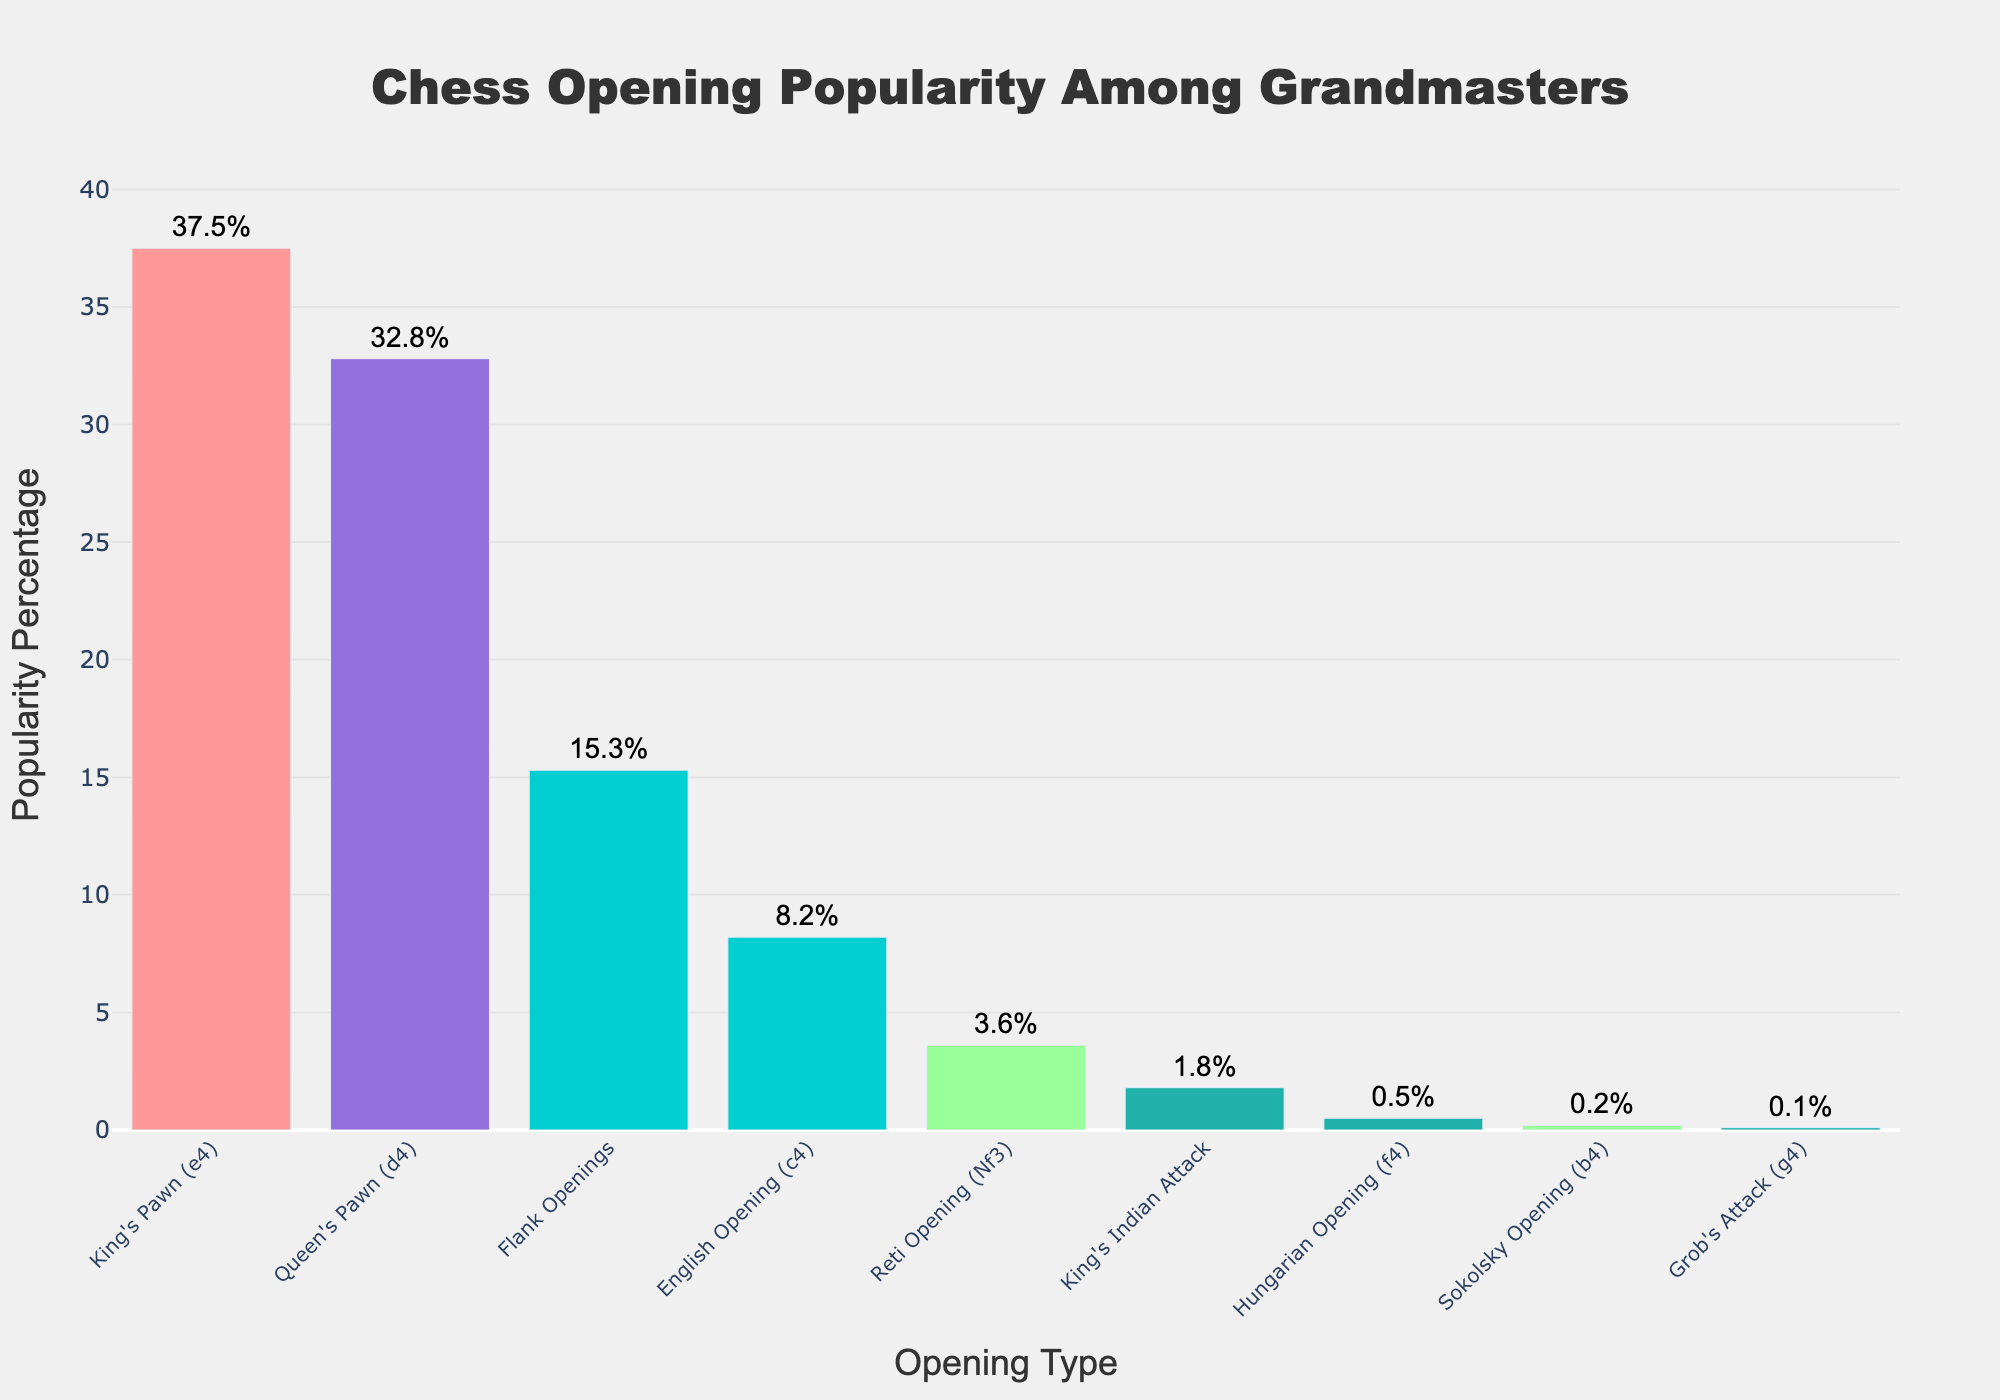What is the most popular chess opening type among grandmasters? The bar chart shows that the opening type with the highest popularity percentage is the King's Pawn (e4). The bar representing King's Pawn (e4) is the tallest, indicating that it has the highest popularity percentage.
Answer: King's Pawn (e4) Which opening type has a lower popularity percentage, Flank Openings or English Opening (c4)? Comparing the heights of the bars for Flank Openings and English Opening (c4), the bar for Flank Openings is taller, indicating a higher popularity percentage. Therefore, English Opening (c4) has a lower popularity percentage.
Answer: English Opening (c4) What is the combined popularity percentage of openings that include a pawn move (e4, d4, c4, b4)? Sum the popularity percentages of King's Pawn (e4), Queen's Pawn (d4), English Opening (c4), and Sokolsky Opening (b4): 37.5 + 32.8 + 8.2 + 0.2. This step-by-step sum results in a combined total.
Answer: 78.7% Among King's Indian Attack and Hungarian Opening (f4), which one is more popular and by how much? The height comparison of the bars shows that King's Indian Attack (1.8%) has a taller bar, thus higher popularity than Hungarian Opening (f4) (0.5%). The difference is calculated by subtracting the percentages: 1.8 - 0.5.
Answer: King's Indian Attack by 1.3% What is the difference in popularity between the most and least popular openings? Identify the percentage for the most popular opening, King's Pawn (e4) at 37.5%, and the least popular opening, Grob's Attack (g4) at 0.1%. Subtract to find the difference: 37.5 - 0.1.
Answer: 37.4% Which opening type is just as popular as the combination of Reti Opening (Nf3) and Hungarian Opening (f4)? Add the popularity percentages of Reti Opening (Nf3) (3.6%) and Hungarian Opening (f4) (0.5%): 3.6 + 0.5. The result is 4.1%.  Observe that none of the other opening types has exactly this percentage, allowing for rough comparison with neighboring values.
Answer: None, roughly close to King's Indian Attack by aggregation logic If you add the popularity percentages of Queen's Pawn (d4) and Reti Opening (Nf3), what category would be close to the resulting percentage? Add Queen's Pawn (d4) (32.8%) and Reti Opening (Nf3) (3.6%): 32.8 + 3.6 equals 36.4. Compare this value to other categories' percentages, knowing it’s close to King's Pawn (e4) at 37.5%.
Answer: Close to King's Pawn (e4) Is there any opening type with a popularity percentage between 5% and 10%? Scan through the popularity percentages for all types, look for bars representing percentages in the stipulated range. Identify English Opening (c4) with 8.2%, falling within this range.
Answer: Yes, English Opening (c4) Of the openings with less than 5% popularity, which one has the highest percentage? Filter out the opening types with percentages below 5%. Among those (Reti Opening (Nf3), King's Indian Attack, Hungarian Opening, Sokolsky Opening, Grob's Attack), the tallest bar among them is Reti Opening (Nf3) with 3.6%.
Answer: Reti Opening (Nf3) 